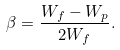Convert formula to latex. <formula><loc_0><loc_0><loc_500><loc_500>\beta = \frac { W _ { f } - W _ { p } } { 2 W _ { f } } .</formula> 